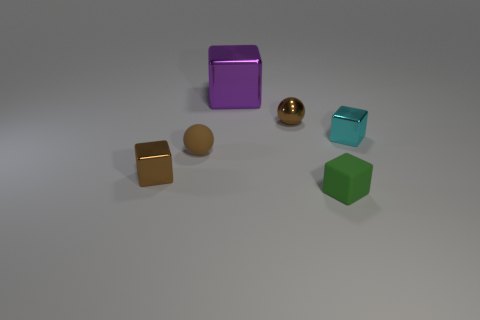What is the material of the other small sphere that is the same color as the shiny ball?
Ensure brevity in your answer.  Rubber. What size is the rubber sphere that is the same color as the metal ball?
Your response must be concise. Small. Are there any other things that have the same material as the small green object?
Provide a short and direct response. Yes. Is the number of small gray matte cubes greater than the number of brown shiny balls?
Make the answer very short. No. What is the shape of the thing in front of the small metallic block that is in front of the thing that is to the right of the small green cube?
Your answer should be very brief. Cube. Is the thing that is on the right side of the green thing made of the same material as the object in front of the small brown cube?
Make the answer very short. No. There is a small cyan thing that is the same material as the big purple cube; what is its shape?
Offer a terse response. Cube. Is there any other thing that is the same color as the small matte block?
Your answer should be compact. No. How many tiny shiny spheres are there?
Provide a short and direct response. 1. What material is the tiny brown sphere that is to the left of the tiny brown metallic thing that is behind the small cyan metallic cube?
Give a very brief answer. Rubber. 